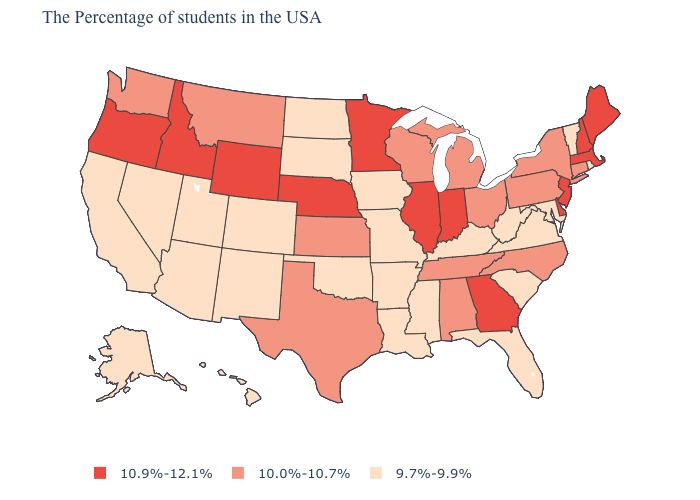Does the first symbol in the legend represent the smallest category?
Write a very short answer. No. Name the states that have a value in the range 10.9%-12.1%?
Short answer required. Maine, Massachusetts, New Hampshire, New Jersey, Delaware, Georgia, Indiana, Illinois, Minnesota, Nebraska, Wyoming, Idaho, Oregon. Name the states that have a value in the range 9.7%-9.9%?
Keep it brief. Rhode Island, Vermont, Maryland, Virginia, South Carolina, West Virginia, Florida, Kentucky, Mississippi, Louisiana, Missouri, Arkansas, Iowa, Oklahoma, South Dakota, North Dakota, Colorado, New Mexico, Utah, Arizona, Nevada, California, Alaska, Hawaii. Which states hav the highest value in the West?
Concise answer only. Wyoming, Idaho, Oregon. Does Hawaii have the lowest value in the USA?
Short answer required. Yes. What is the lowest value in states that border Mississippi?
Keep it brief. 9.7%-9.9%. Name the states that have a value in the range 10.0%-10.7%?
Quick response, please. Connecticut, New York, Pennsylvania, North Carolina, Ohio, Michigan, Alabama, Tennessee, Wisconsin, Kansas, Texas, Montana, Washington. Name the states that have a value in the range 9.7%-9.9%?
Short answer required. Rhode Island, Vermont, Maryland, Virginia, South Carolina, West Virginia, Florida, Kentucky, Mississippi, Louisiana, Missouri, Arkansas, Iowa, Oklahoma, South Dakota, North Dakota, Colorado, New Mexico, Utah, Arizona, Nevada, California, Alaska, Hawaii. What is the value of Louisiana?
Be succinct. 9.7%-9.9%. What is the value of Nevada?
Give a very brief answer. 9.7%-9.9%. What is the highest value in the West ?
Write a very short answer. 10.9%-12.1%. Which states have the highest value in the USA?
Give a very brief answer. Maine, Massachusetts, New Hampshire, New Jersey, Delaware, Georgia, Indiana, Illinois, Minnesota, Nebraska, Wyoming, Idaho, Oregon. What is the value of Montana?
Answer briefly. 10.0%-10.7%. Does California have the lowest value in the USA?
Give a very brief answer. Yes. Among the states that border New Mexico , does Texas have the lowest value?
Concise answer only. No. 